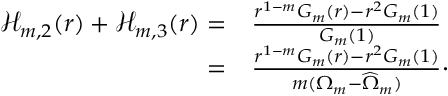Convert formula to latex. <formula><loc_0><loc_0><loc_500><loc_500>\begin{array} { r l } { \mathcal { H } _ { m , 2 } ( r ) + \mathcal { H } _ { m , 3 } ( r ) = } & { \frac { r ^ { 1 - m } G _ { m } ( r ) - r ^ { 2 } G _ { m } ( 1 ) } { G _ { m } ( 1 ) } } \\ { = } & { \frac { r ^ { 1 - m } G _ { m } ( r ) - r ^ { 2 } G _ { m } ( 1 ) } { m ( { \Omega _ { m } } - \widehat { \Omega } _ { m } ) } \cdot } \end{array}</formula> 